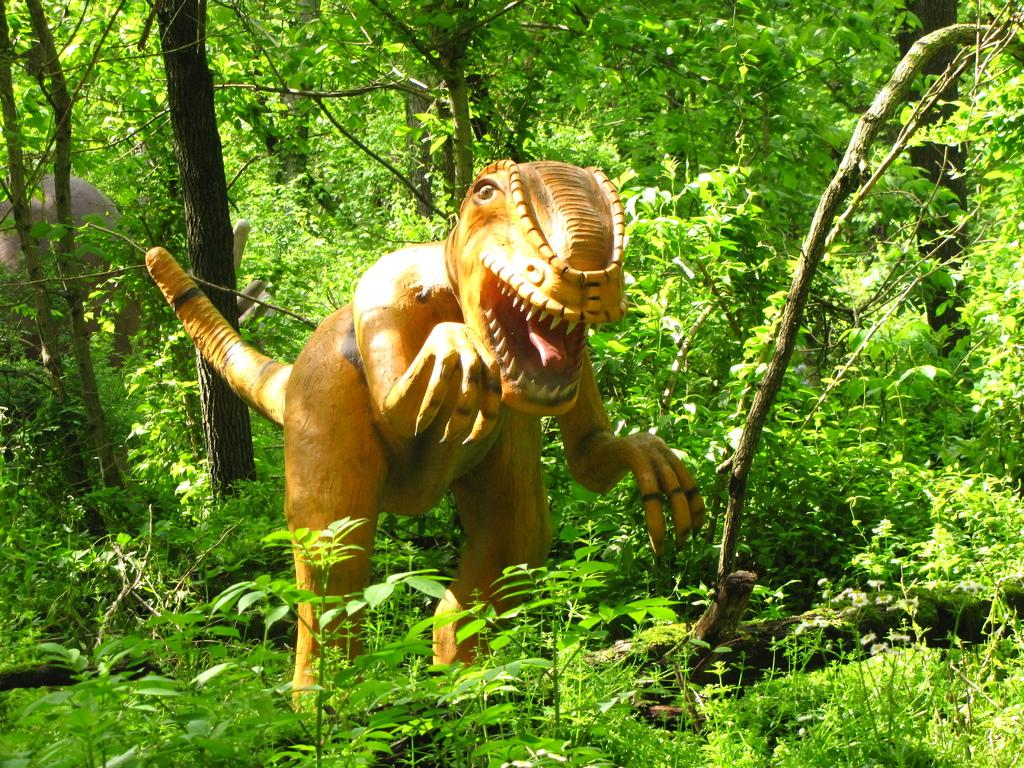What type of object is on the ground in the image? There is a toy of an animal on the ground. What can be seen in the background of the image? There are trees visible in the background of the image. Where is the cushion placed in the image? There is no cushion present in the image. What is the animal's stomach doing in the image? The toy animal does not have a stomach, as it is an inanimate object. 